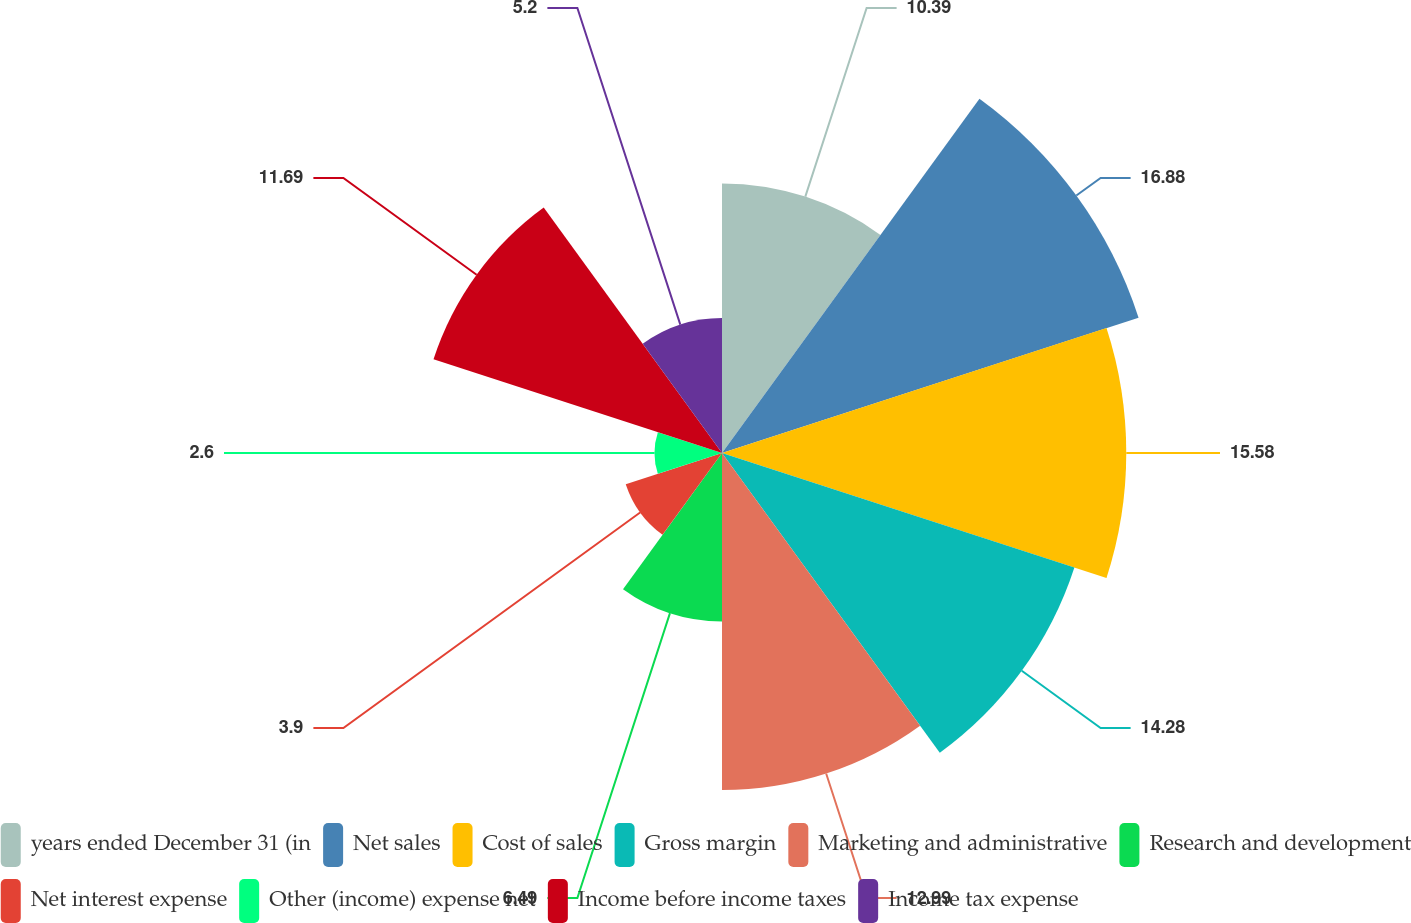Convert chart. <chart><loc_0><loc_0><loc_500><loc_500><pie_chart><fcel>years ended December 31 (in<fcel>Net sales<fcel>Cost of sales<fcel>Gross margin<fcel>Marketing and administrative<fcel>Research and development<fcel>Net interest expense<fcel>Other (income) expense net<fcel>Income before income taxes<fcel>Income tax expense<nl><fcel>10.39%<fcel>16.88%<fcel>15.58%<fcel>14.28%<fcel>12.99%<fcel>6.49%<fcel>3.9%<fcel>2.6%<fcel>11.69%<fcel>5.2%<nl></chart> 